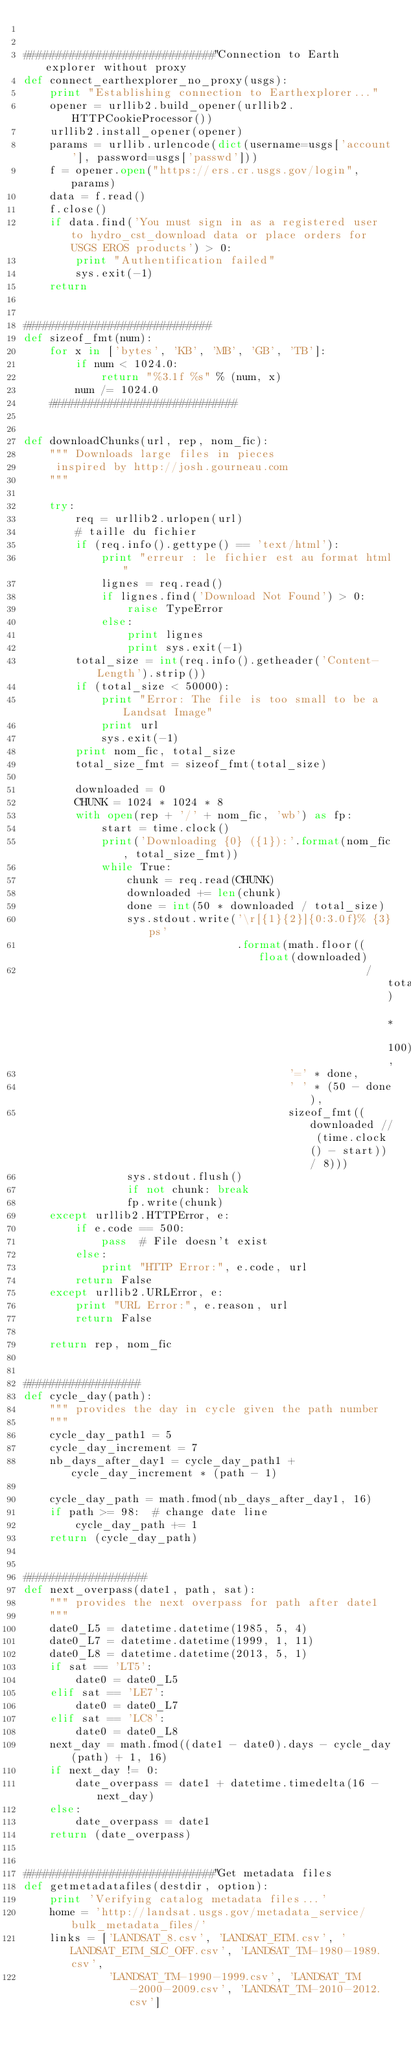Convert code to text. <code><loc_0><loc_0><loc_500><loc_500><_Python_>

#############################"Connection to Earth explorer without proxy
def connect_earthexplorer_no_proxy(usgs):
    print "Establishing connection to Earthexplorer..."
    opener = urllib2.build_opener(urllib2.HTTPCookieProcessor())
    urllib2.install_opener(opener)
    params = urllib.urlencode(dict(username=usgs['account'], password=usgs['passwd']))
    f = opener.open("https://ers.cr.usgs.gov/login", params)
    data = f.read()
    f.close()
    if data.find('You must sign in as a registered user to hydro_cst_download data or place orders for USGS EROS products') > 0:
        print "Authentification failed"
        sys.exit(-1)
    return


#############################
def sizeof_fmt(num):
    for x in ['bytes', 'KB', 'MB', 'GB', 'TB']:
        if num < 1024.0:
            return "%3.1f %s" % (num, x)
        num /= 1024.0
    #############################


def downloadChunks(url, rep, nom_fic):
    """ Downloads large files in pieces
     inspired by http://josh.gourneau.com
    """

    try:
        req = urllib2.urlopen(url)
        # taille du fichier
        if (req.info().gettype() == 'text/html'):
            print "erreur : le fichier est au format html"
            lignes = req.read()
            if lignes.find('Download Not Found') > 0:
                raise TypeError
            else:
                print lignes
                print sys.exit(-1)
        total_size = int(req.info().getheader('Content-Length').strip())
        if (total_size < 50000):
            print "Error: The file is too small to be a Landsat Image"
            print url
            sys.exit(-1)
        print nom_fic, total_size
        total_size_fmt = sizeof_fmt(total_size)

        downloaded = 0
        CHUNK = 1024 * 1024 * 8
        with open(rep + '/' + nom_fic, 'wb') as fp:
            start = time.clock()
            print('Downloading {0} ({1}):'.format(nom_fic, total_size_fmt))
            while True:
                chunk = req.read(CHUNK)
                downloaded += len(chunk)
                done = int(50 * downloaded / total_size)
                sys.stdout.write('\r[{1}{2}]{0:3.0f}% {3}ps'
                                 .format(math.floor((float(downloaded)
                                                     / total_size) * 100),
                                         '=' * done,
                                         ' ' * (50 - done),
                                         sizeof_fmt((downloaded // (time.clock() - start)) / 8)))
                sys.stdout.flush()
                if not chunk: break
                fp.write(chunk)
    except urllib2.HTTPError, e:
        if e.code == 500:
            pass  # File doesn't exist
        else:
            print "HTTP Error:", e.code, url
        return False
    except urllib2.URLError, e:
        print "URL Error:", e.reason, url
        return False

    return rep, nom_fic


##################
def cycle_day(path):
    """ provides the day in cycle given the path number
    """
    cycle_day_path1 = 5
    cycle_day_increment = 7
    nb_days_after_day1 = cycle_day_path1 + cycle_day_increment * (path - 1)

    cycle_day_path = math.fmod(nb_days_after_day1, 16)
    if path >= 98:  # change date line
        cycle_day_path += 1
    return (cycle_day_path)


###################
def next_overpass(date1, path, sat):
    """ provides the next overpass for path after date1
    """
    date0_L5 = datetime.datetime(1985, 5, 4)
    date0_L7 = datetime.datetime(1999, 1, 11)
    date0_L8 = datetime.datetime(2013, 5, 1)
    if sat == 'LT5':
        date0 = date0_L5
    elif sat == 'LE7':
        date0 = date0_L7
    elif sat == 'LC8':
        date0 = date0_L8
    next_day = math.fmod((date1 - date0).days - cycle_day(path) + 1, 16)
    if next_day != 0:
        date_overpass = date1 + datetime.timedelta(16 - next_day)
    else:
        date_overpass = date1
    return (date_overpass)


#############################"Get metadata files
def getmetadatafiles(destdir, option):
    print 'Verifying catalog metadata files...'
    home = 'http://landsat.usgs.gov/metadata_service/bulk_metadata_files/'
    links = ['LANDSAT_8.csv', 'LANDSAT_ETM.csv', 'LANDSAT_ETM_SLC_OFF.csv', 'LANDSAT_TM-1980-1989.csv',
             'LANDSAT_TM-1990-1999.csv', 'LANDSAT_TM-2000-2009.csv', 'LANDSAT_TM-2010-2012.csv']</code> 